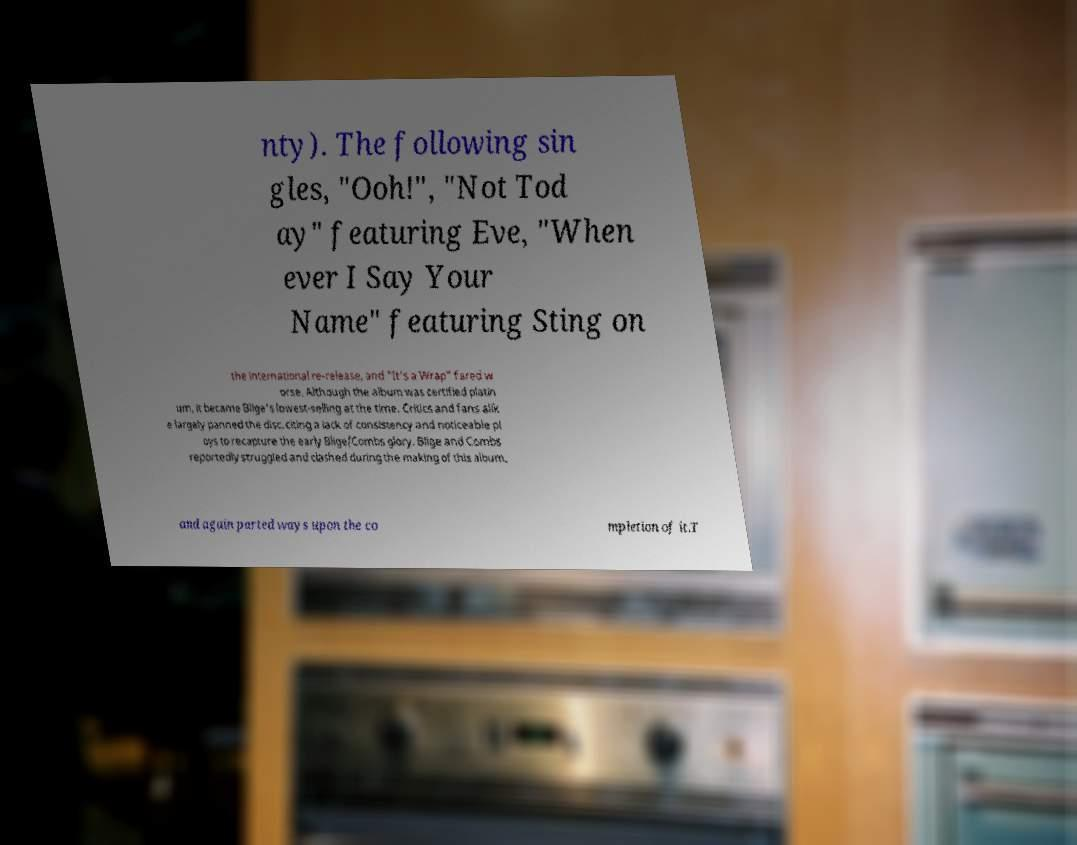Could you assist in decoding the text presented in this image and type it out clearly? nty). The following sin gles, "Ooh!", "Not Tod ay" featuring Eve, "When ever I Say Your Name" featuring Sting on the international re-release, and "It's a Wrap" fared w orse. Although the album was certified platin um, it became Blige's lowest-selling at the time. Critics and fans alik e largely panned the disc, citing a lack of consistency and noticeable pl oys to recapture the early Blige/Combs glory. Blige and Combs reportedly struggled and clashed during the making of this album, and again parted ways upon the co mpletion of it.T 